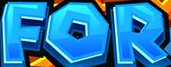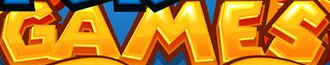What words can you see in these images in sequence, separated by a semicolon? FOR; GAMES 